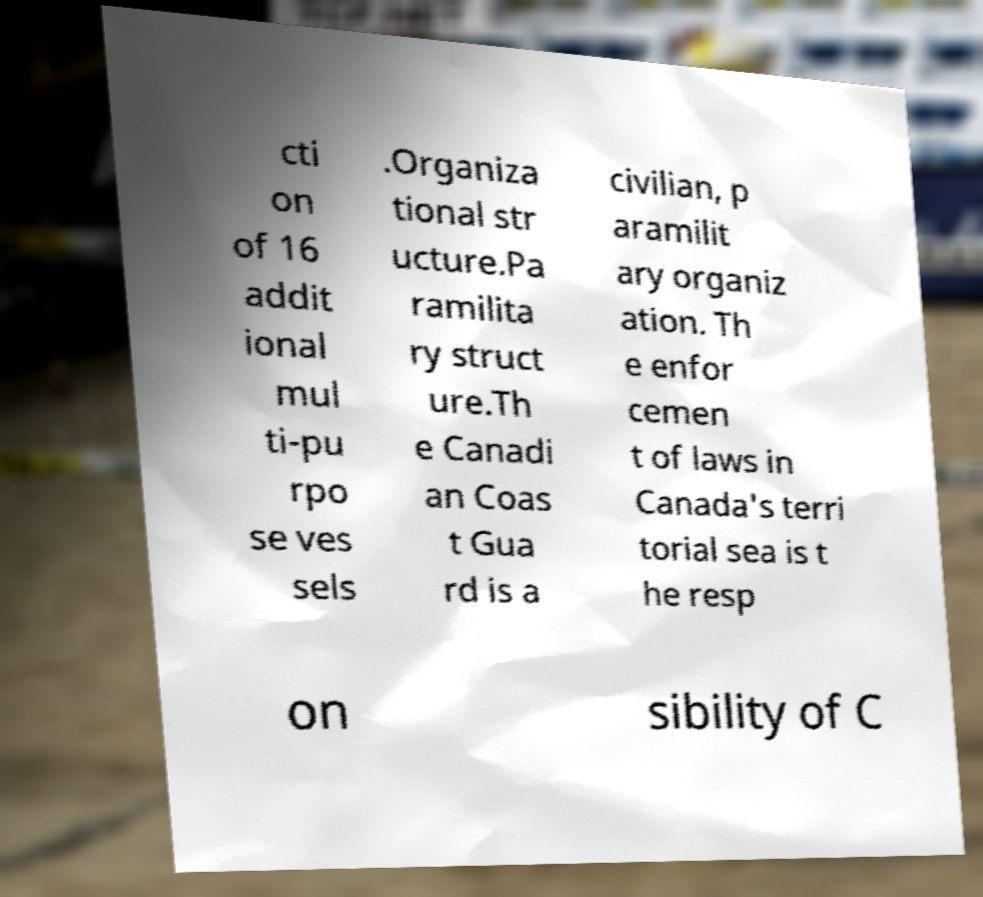Could you extract and type out the text from this image? cti on of 16 addit ional mul ti-pu rpo se ves sels .Organiza tional str ucture.Pa ramilita ry struct ure.Th e Canadi an Coas t Gua rd is a civilian, p aramilit ary organiz ation. Th e enfor cemen t of laws in Canada's terri torial sea is t he resp on sibility of C 